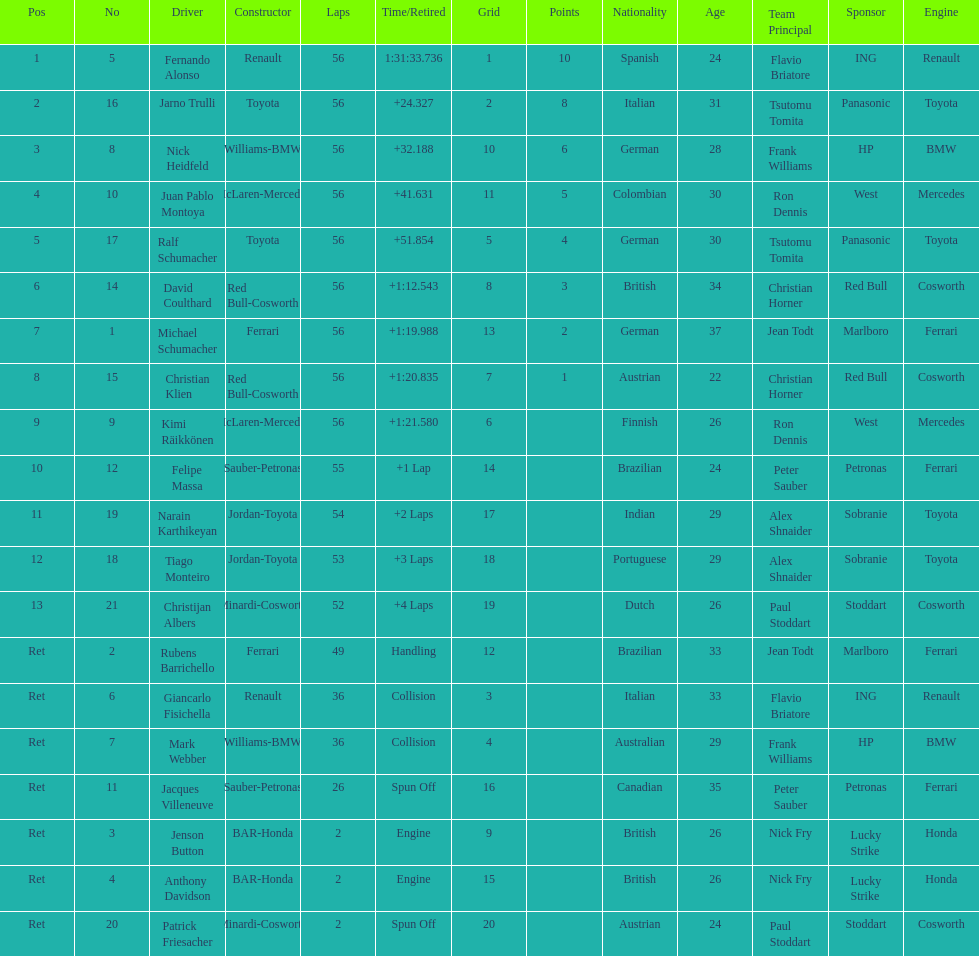Who was the last driver from the uk to actually finish the 56 laps? David Coulthard. 